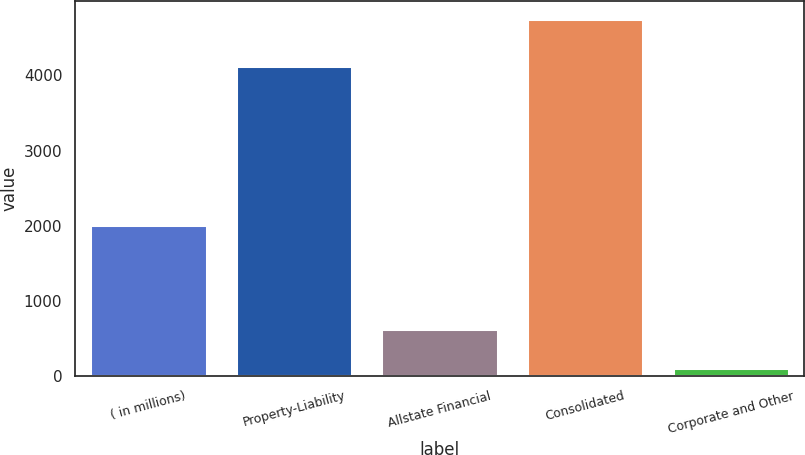Convert chart to OTSL. <chart><loc_0><loc_0><loc_500><loc_500><bar_chart><fcel>( in millions)<fcel>Property-Liability<fcel>Allstate Financial<fcel>Consolidated<fcel>Corporate and Other<nl><fcel>2006<fcel>4131<fcel>626<fcel>4757<fcel>106<nl></chart> 